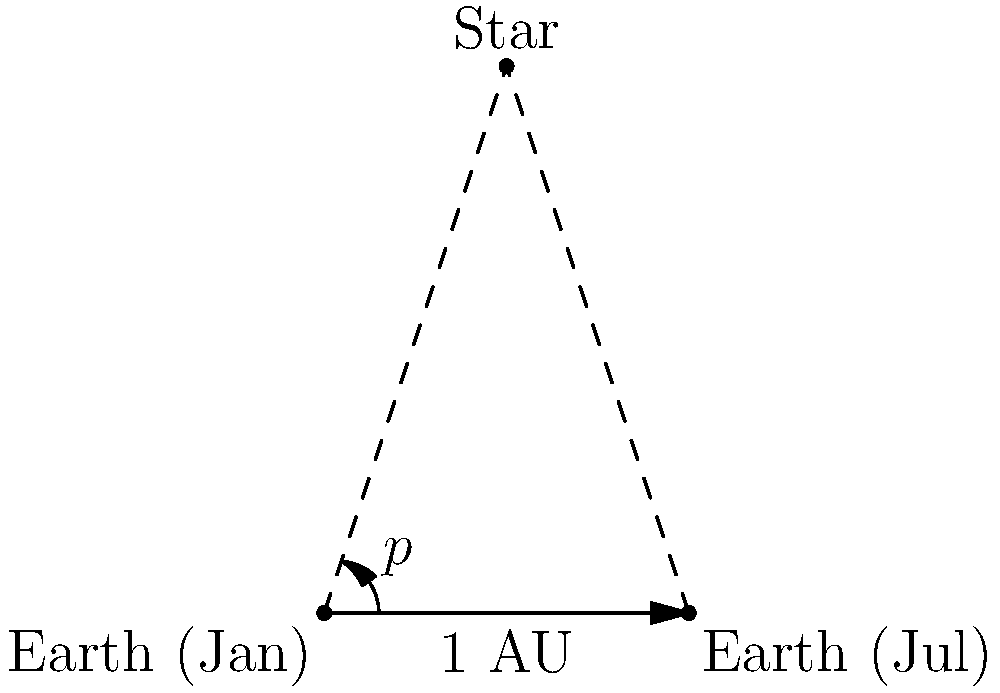As a cloud platform specialist, you're developing a space-themed application that calculates astronomical distances. You need to implement a function to determine the distance to a star using parallax measurements. Given that the parallax angle $p$ is 0.5 arcseconds and Earth's orbit radius (1 AU) is approximately 1.496 × 10^8 km, what is the distance to the star in parsecs? To calculate the distance to a star using parallax measurements, we can follow these steps:

1. Recall the definition of a parsec: 1 parsec is the distance at which an object has a parallax of 1 arcsecond.

2. The formula for distance in parsecs is:

   $$ d = \frac{1}{p} $$

   where $d$ is the distance in parsecs and $p$ is the parallax angle in arcseconds.

3. Given information:
   - Parallax angle $p = 0.5$ arcseconds
   - 1 AU ≈ 1.496 × 10^8 km (not directly used in this calculation)

4. Apply the formula:

   $$ d = \frac{1}{0.5} = 2 \text{ parsecs} $$

5. Therefore, the star is 2 parsecs away from Earth.

Note: In a cloud-based application, you would implement this as a function that takes the parallax angle as input and returns the distance in parsecs.
Answer: 2 parsecs 